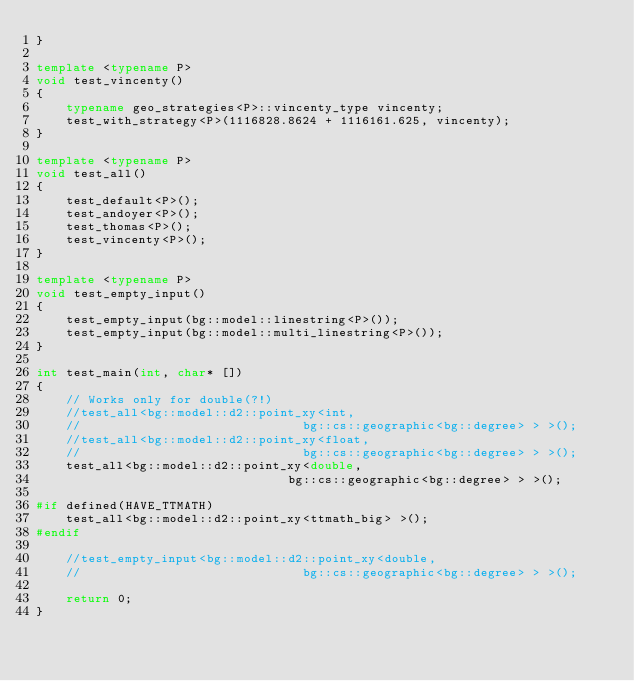<code> <loc_0><loc_0><loc_500><loc_500><_C++_>}

template <typename P>
void test_vincenty()
{
    typename geo_strategies<P>::vincenty_type vincenty;
    test_with_strategy<P>(1116828.8624 + 1116161.625, vincenty);
}

template <typename P>
void test_all()
{
    test_default<P>();
    test_andoyer<P>();
    test_thomas<P>();
    test_vincenty<P>();
}

template <typename P>
void test_empty_input()
{
    test_empty_input(bg::model::linestring<P>());
    test_empty_input(bg::model::multi_linestring<P>());
}

int test_main(int, char* [])
{
    // Works only for double(?!)
    //test_all<bg::model::d2::point_xy<int,
    //                              bg::cs::geographic<bg::degree> > >();
    //test_all<bg::model::d2::point_xy<float,
    //                              bg::cs::geographic<bg::degree> > >();
    test_all<bg::model::d2::point_xy<double,
                                  bg::cs::geographic<bg::degree> > >();

#if defined(HAVE_TTMATH)
    test_all<bg::model::d2::point_xy<ttmath_big> >();
#endif

    //test_empty_input<bg::model::d2::point_xy<double,
    //                              bg::cs::geographic<bg::degree> > >();

    return 0;
}

</code> 